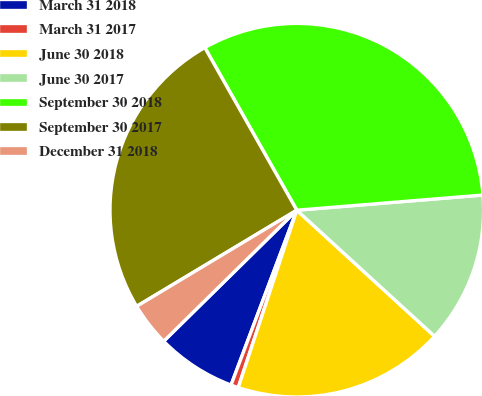<chart> <loc_0><loc_0><loc_500><loc_500><pie_chart><fcel>March 31 2018<fcel>March 31 2017<fcel>June 30 2018<fcel>June 30 2017<fcel>September 30 2018<fcel>September 30 2017<fcel>December 31 2018<nl><fcel>6.9%<fcel>0.65%<fcel>18.28%<fcel>13.09%<fcel>31.9%<fcel>25.41%<fcel>3.77%<nl></chart> 